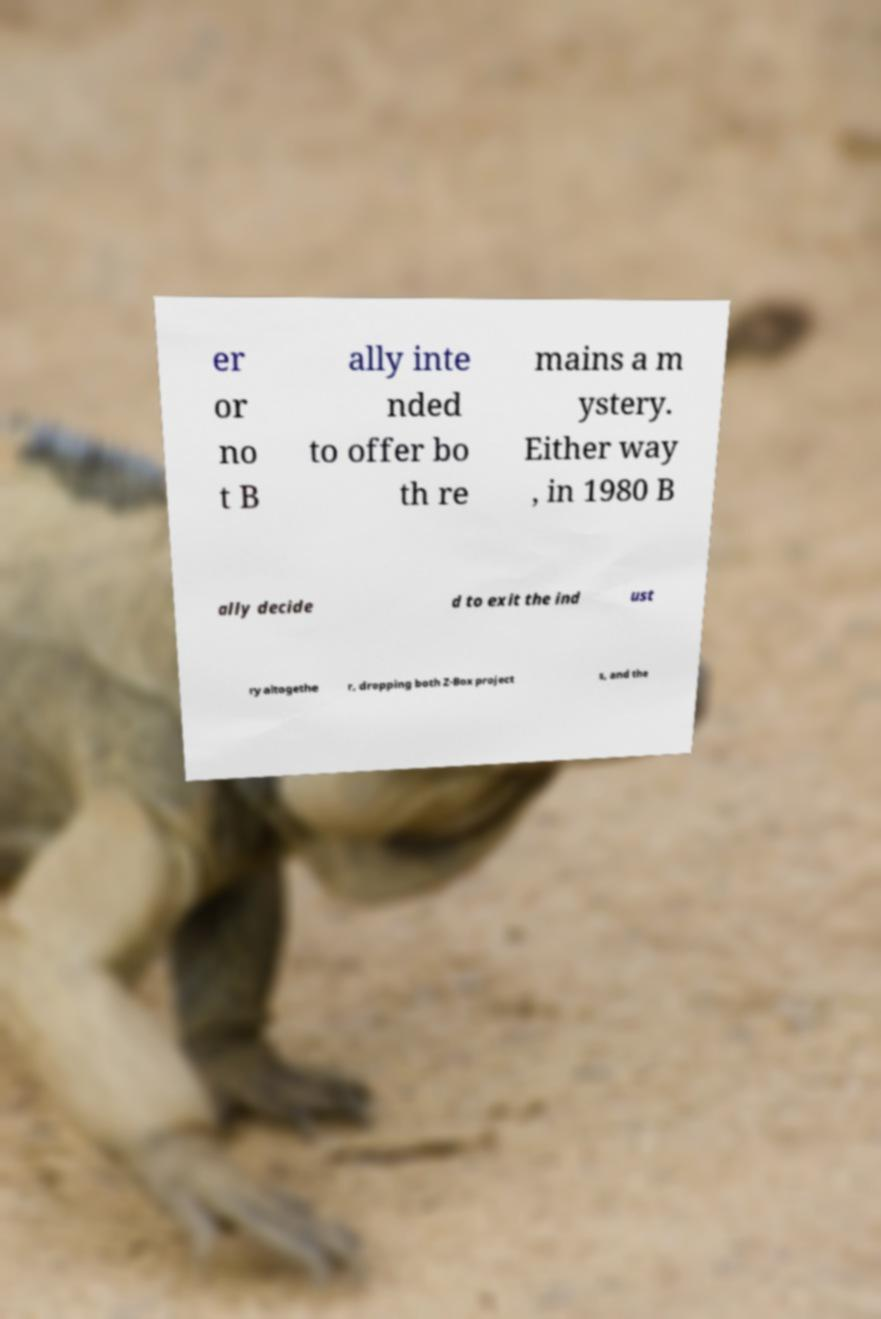Could you assist in decoding the text presented in this image and type it out clearly? er or no t B ally inte nded to offer bo th re mains a m ystery. Either way , in 1980 B ally decide d to exit the ind ust ry altogethe r, dropping both Z-Box project s, and the 